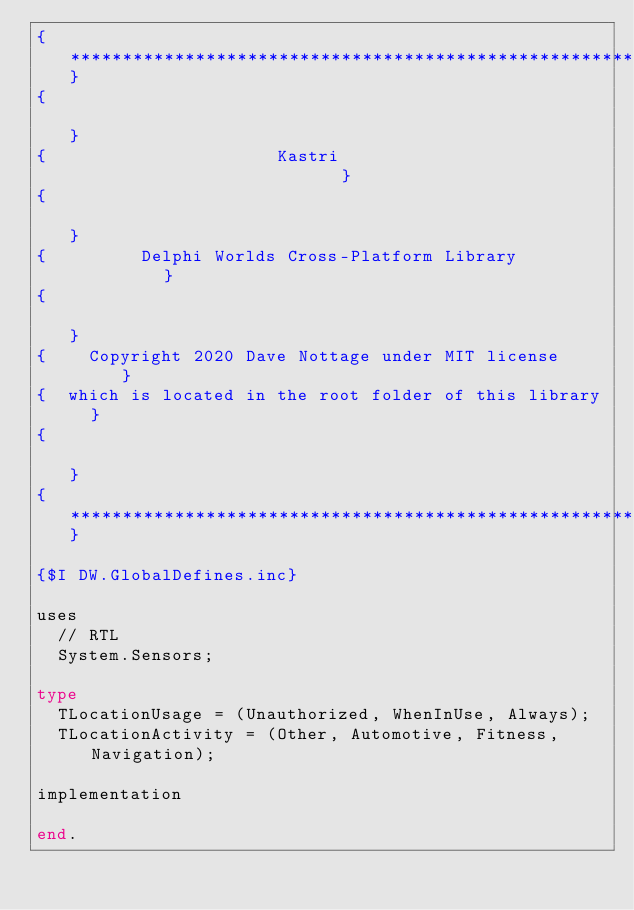<code> <loc_0><loc_0><loc_500><loc_500><_Pascal_>{*******************************************************}
{                                                       }
{                      Kastri                           }
{                                                       }
{         Delphi Worlds Cross-Platform Library          }
{                                                       }
{    Copyright 2020 Dave Nottage under MIT license      }
{  which is located in the root folder of this library  }
{                                                       }
{*******************************************************}

{$I DW.GlobalDefines.inc}

uses
  // RTL
  System.Sensors;

type
  TLocationUsage = (Unauthorized, WhenInUse, Always);
  TLocationActivity = (Other, Automotive, Fitness, Navigation);

implementation

end.
</code> 